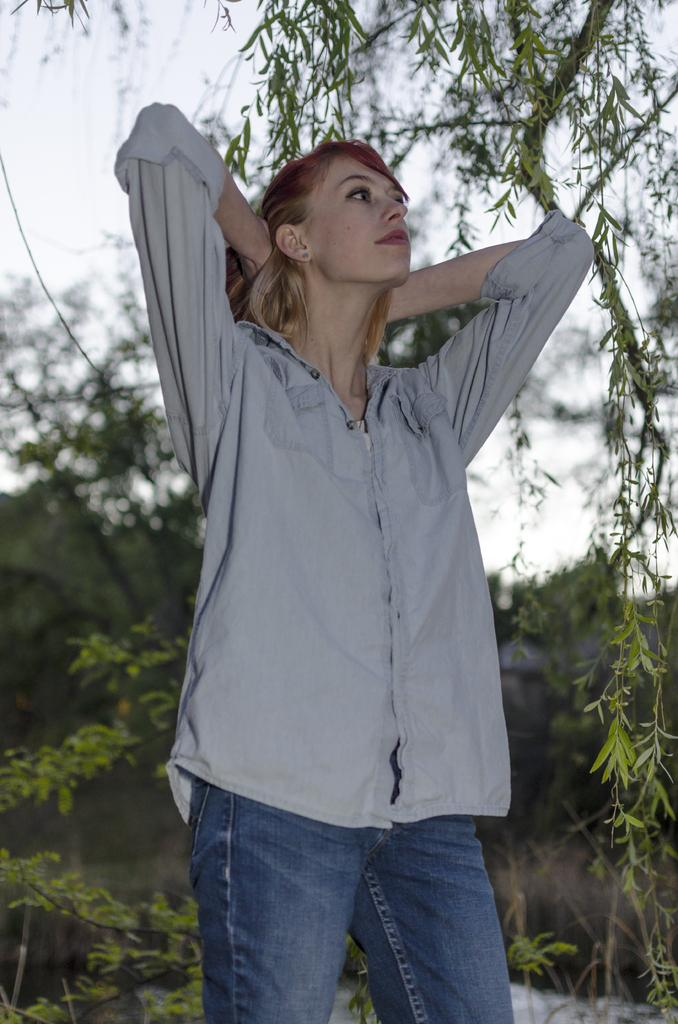Who is the main subject in the image? There is a woman in the image. What can be seen in the background behind the woman? There are trees behind the woman in the image. What type of credit does the woman's dad offer in the image? There is no mention of credit or the woman's dad in the image, so this question cannot be answered. 